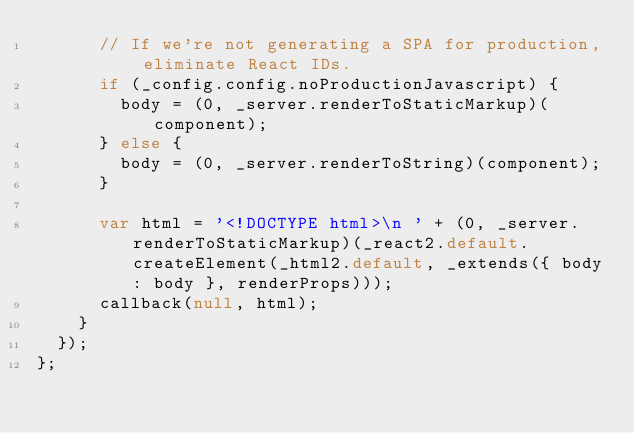Convert code to text. <code><loc_0><loc_0><loc_500><loc_500><_JavaScript_>      // If we're not generating a SPA for production, eliminate React IDs.
      if (_config.config.noProductionJavascript) {
        body = (0, _server.renderToStaticMarkup)(component);
      } else {
        body = (0, _server.renderToString)(component);
      }

      var html = '<!DOCTYPE html>\n ' + (0, _server.renderToStaticMarkup)(_react2.default.createElement(_html2.default, _extends({ body: body }, renderProps)));
      callback(null, html);
    }
  });
};</code> 